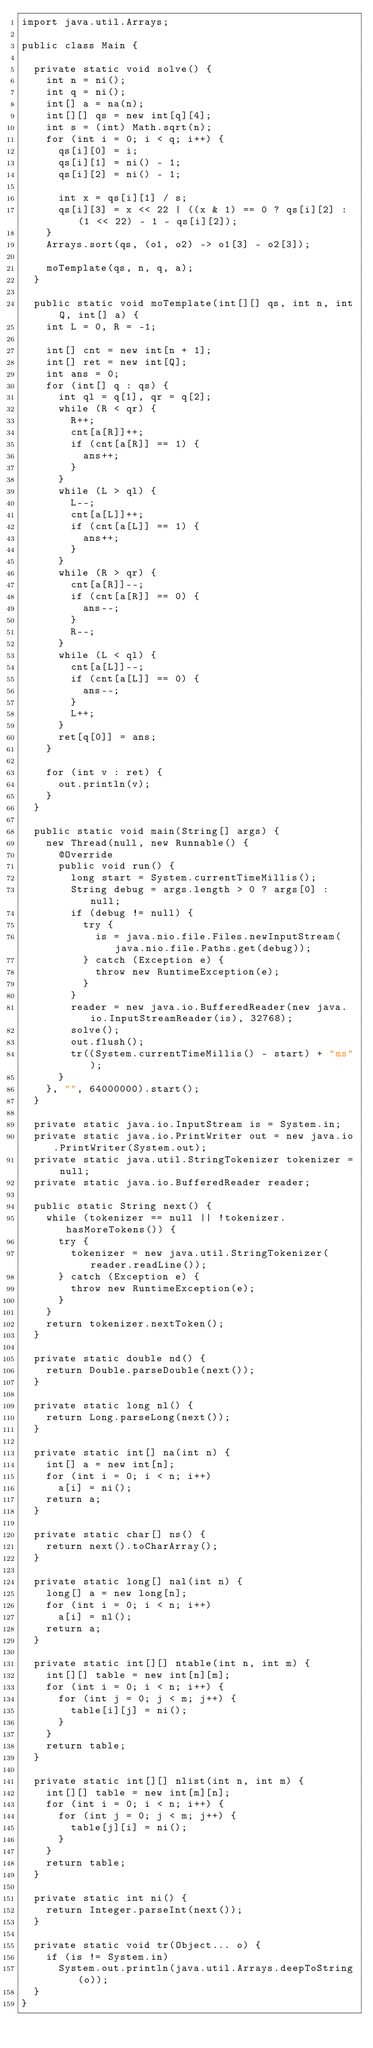Convert code to text. <code><loc_0><loc_0><loc_500><loc_500><_Java_>import java.util.Arrays;

public class Main {

  private static void solve() {
    int n = ni();
    int q = ni();
    int[] a = na(n);
    int[][] qs = new int[q][4];
    int s = (int) Math.sqrt(n);
    for (int i = 0; i < q; i++) {
      qs[i][0] = i;
      qs[i][1] = ni() - 1;
      qs[i][2] = ni() - 1;

      int x = qs[i][1] / s;
      qs[i][3] = x << 22 | ((x & 1) == 0 ? qs[i][2] : (1 << 22) - 1 - qs[i][2]);
    }
    Arrays.sort(qs, (o1, o2) -> o1[3] - o2[3]);

    moTemplate(qs, n, q, a);
  }

  public static void moTemplate(int[][] qs, int n, int Q, int[] a) {
    int L = 0, R = -1;

    int[] cnt = new int[n + 1];
    int[] ret = new int[Q];
    int ans = 0;
    for (int[] q : qs) {
      int ql = q[1], qr = q[2];
      while (R < qr) {
        R++;
        cnt[a[R]]++;
        if (cnt[a[R]] == 1) {
          ans++;
        }
      }
      while (L > ql) {
        L--;
        cnt[a[L]]++;
        if (cnt[a[L]] == 1) {
          ans++;
        }
      }
      while (R > qr) {
        cnt[a[R]]--;
        if (cnt[a[R]] == 0) {
          ans--;
        }
        R--;
      }
      while (L < ql) {
        cnt[a[L]]--;
        if (cnt[a[L]] == 0) {
          ans--;
        }
        L++;
      }
      ret[q[0]] = ans;
    }

    for (int v : ret) {
      out.println(v);
    }
  }

  public static void main(String[] args) {
    new Thread(null, new Runnable() {
      @Override
      public void run() {
        long start = System.currentTimeMillis();
        String debug = args.length > 0 ? args[0] : null;
        if (debug != null) {
          try {
            is = java.nio.file.Files.newInputStream(java.nio.file.Paths.get(debug));
          } catch (Exception e) {
            throw new RuntimeException(e);
          }
        }
        reader = new java.io.BufferedReader(new java.io.InputStreamReader(is), 32768);
        solve();
        out.flush();
        tr((System.currentTimeMillis() - start) + "ms");
      }
    }, "", 64000000).start();
  }

  private static java.io.InputStream is = System.in;
  private static java.io.PrintWriter out = new java.io.PrintWriter(System.out);
  private static java.util.StringTokenizer tokenizer = null;
  private static java.io.BufferedReader reader;

  public static String next() {
    while (tokenizer == null || !tokenizer.hasMoreTokens()) {
      try {
        tokenizer = new java.util.StringTokenizer(reader.readLine());
      } catch (Exception e) {
        throw new RuntimeException(e);
      }
    }
    return tokenizer.nextToken();
  }

  private static double nd() {
    return Double.parseDouble(next());
  }

  private static long nl() {
    return Long.parseLong(next());
  }

  private static int[] na(int n) {
    int[] a = new int[n];
    for (int i = 0; i < n; i++)
      a[i] = ni();
    return a;
  }

  private static char[] ns() {
    return next().toCharArray();
  }

  private static long[] nal(int n) {
    long[] a = new long[n];
    for (int i = 0; i < n; i++)
      a[i] = nl();
    return a;
  }

  private static int[][] ntable(int n, int m) {
    int[][] table = new int[n][m];
    for (int i = 0; i < n; i++) {
      for (int j = 0; j < m; j++) {
        table[i][j] = ni();
      }
    }
    return table;
  }

  private static int[][] nlist(int n, int m) {
    int[][] table = new int[m][n];
    for (int i = 0; i < n; i++) {
      for (int j = 0; j < m; j++) {
        table[j][i] = ni();
      }
    }
    return table;
  }

  private static int ni() {
    return Integer.parseInt(next());
  }

  private static void tr(Object... o) {
    if (is != System.in)
      System.out.println(java.util.Arrays.deepToString(o));
  }
}
</code> 